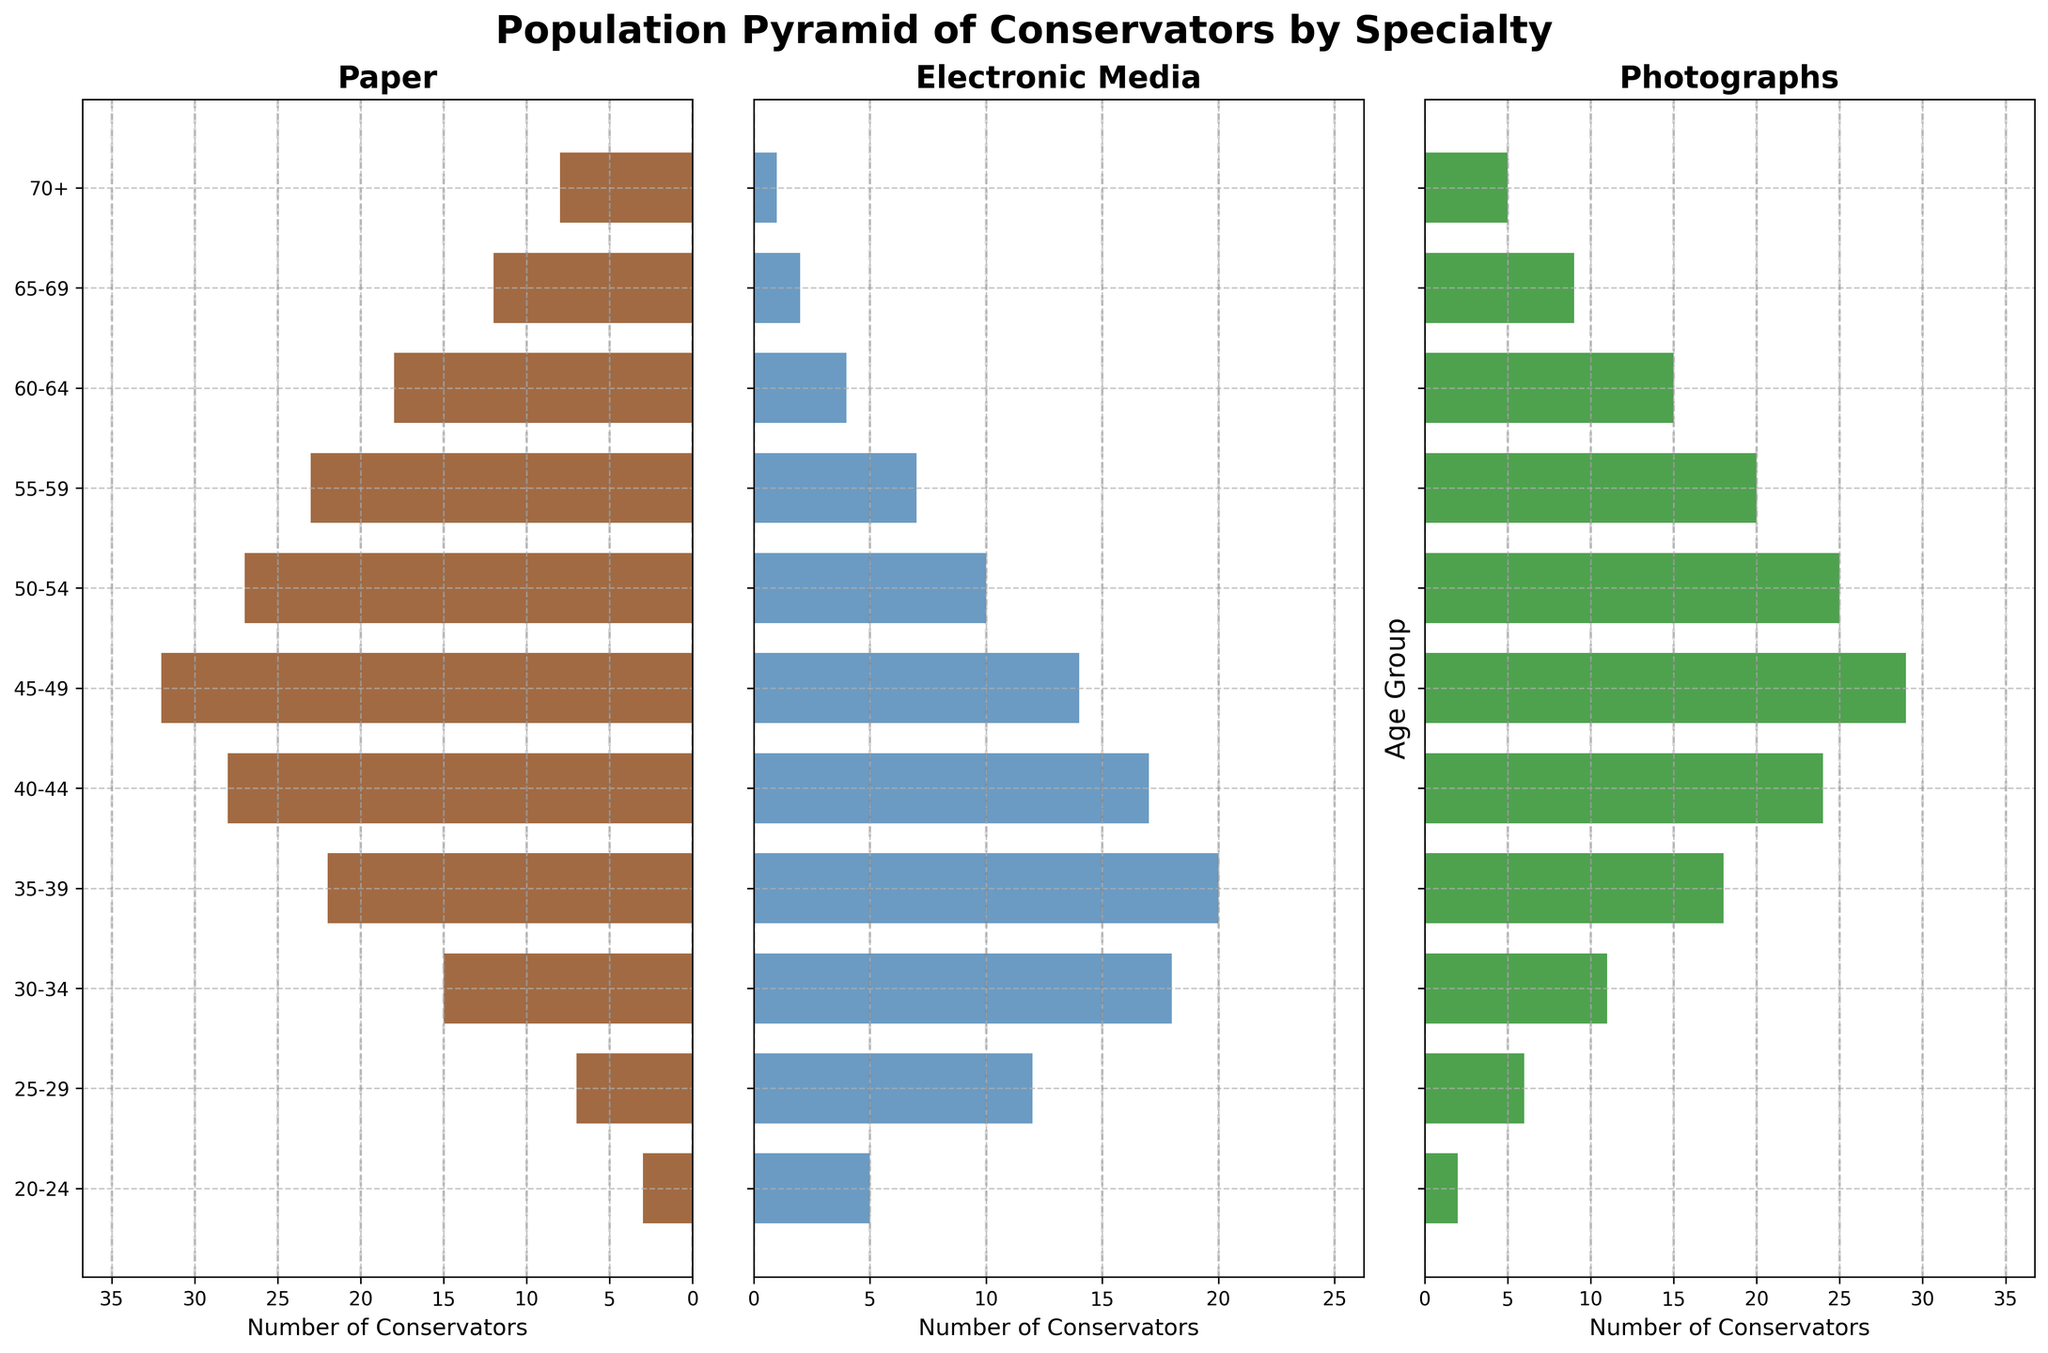What's the title of the population pyramid figure? The title is clearly indicated at the top of the figure. It helps to provide context and understanding of what the chart represents.
Answer: Population Pyramid of Conservators by Specialty What age group has the highest number of conservators specializing in paper? By examining the "Paper" section of the population pyramid, we see that the 45-49 age group has the highest bar.
Answer: 45-49 How many conservators specialize in electronic media and belong to the 30-34 age group? Look at the "Electronic Media" section of the population pyramid and check the bar corresponding to the 30-34 age group.
Answer: 18 Which specialty has the smallest number of conservators in the 70+ age group? Compare the height of the bars for the 70+ age group across all three specialties. The bar for "Electronic Media" is the smallest.
Answer: Electronic Media What is the total number of conservators aged 40-44 across all specialties? Add the number of conservators in the 40-44 age group from each specialty: Paper (28) + Electronic Media (17) + Photographs (24) = 69.
Answer: 69 Compare the number of conservators aged 35-39 specializing in paper and photographs. Which is greater? Look at the bars for the 35-39 age group in both the "Paper" and "Photographs" sections. The bar for photographs is smaller (18) than the bar for paper (22).
Answer: Paper What is the difference in the number of conservators specializing in photographs between the 45-49 and 50-54 age groups? Subtract the number of conservators in the 50-54 age group (25) from the 45-49 age group (29) for the "Photographs" section.
Answer: 4 Which age group shows the highest number of conservators specializing in electronic media? Look at the "Electronic Media" section and identify the age group with the longest bar. This is the 35-39 age group.
Answer: 35-39 What is the average age range of conservators in the paper specialization field? Calculate the average position by summing the number of conservators for all age groups, multiply each by mid-point value, and divide by total number of conservators, which is a step-by-step calculation. (3*22 + 7*27 + 15*32 + 22*37 + 28*42 + 32*47 + 27*52 + 23*57 + 18*62 + 12*67 + 8*75) ÷ (3+7+15+22+28+32+27+23+18+12+8)
Answer: Around 47 Among people aged 55-59, which type of material has the least experienced conservators? Examine the bars for the 55-59 age group in each specialty and find the shortest bar, which is for "Electronic Media".
Answer: Electronic Media 